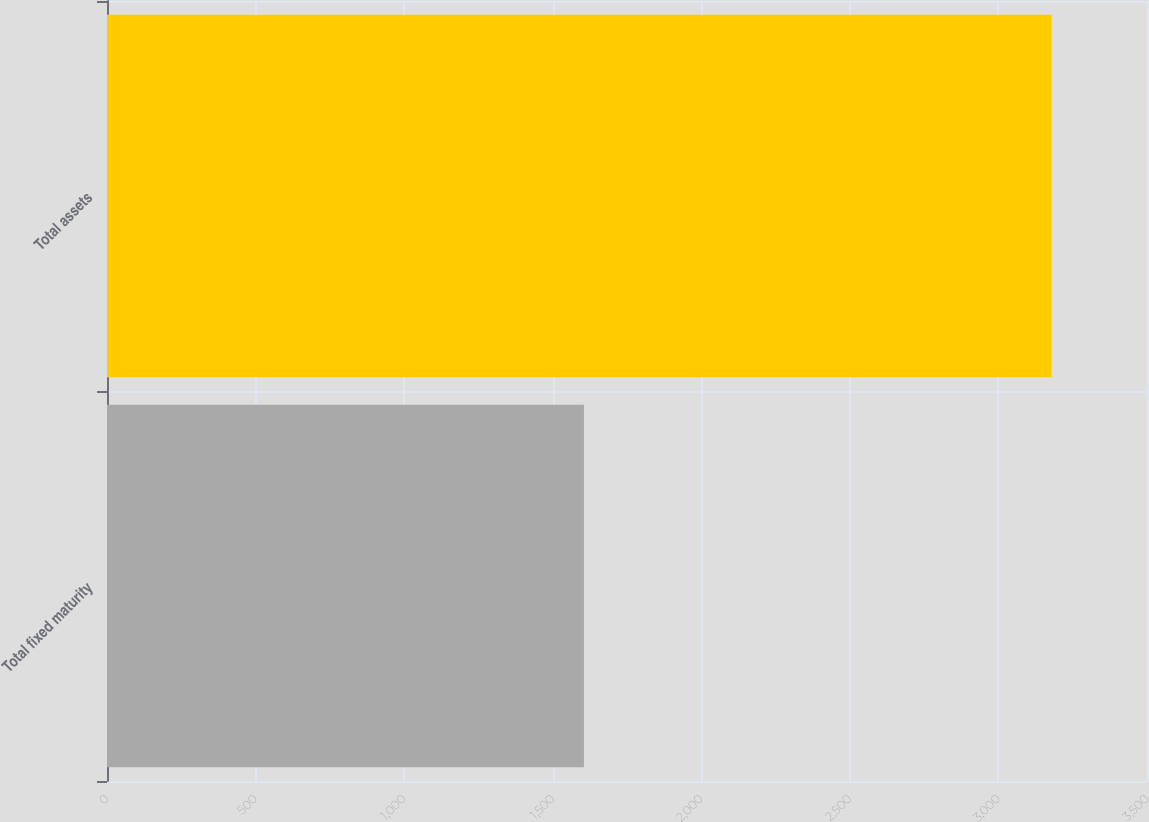<chart> <loc_0><loc_0><loc_500><loc_500><bar_chart><fcel>Total fixed maturity<fcel>Total assets<nl><fcel>1605<fcel>3179<nl></chart> 